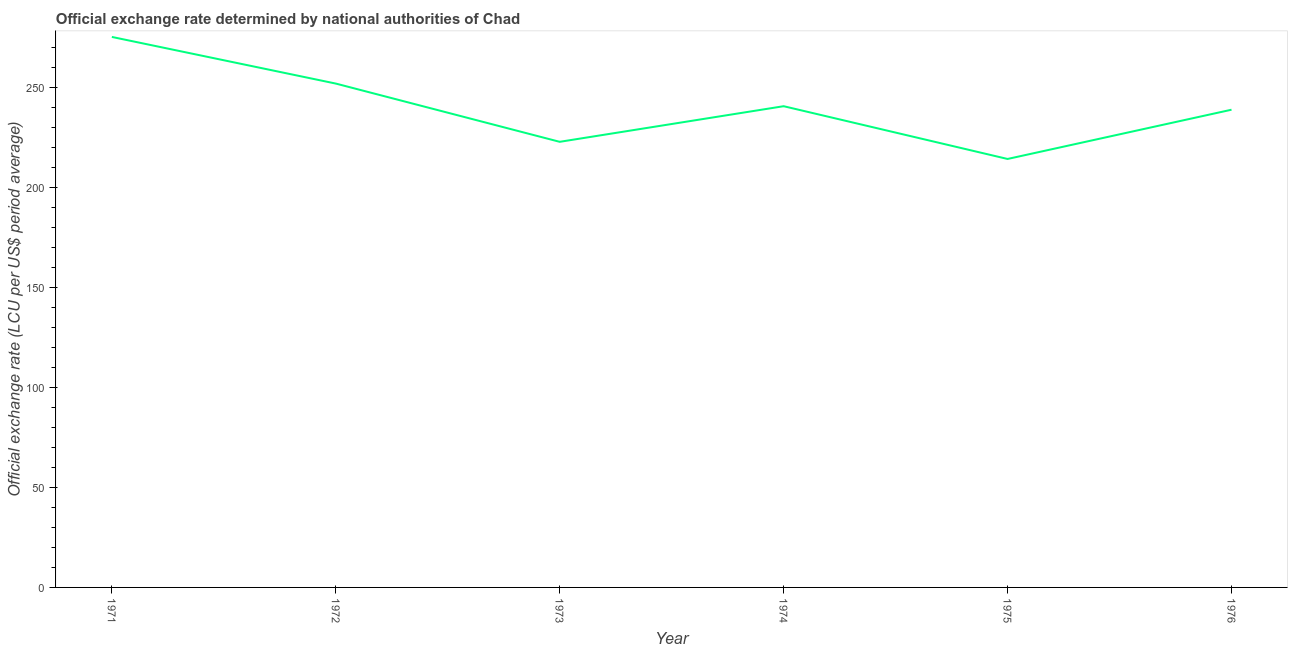What is the official exchange rate in 1975?
Your answer should be compact. 214.31. Across all years, what is the maximum official exchange rate?
Provide a succinct answer. 275.36. Across all years, what is the minimum official exchange rate?
Offer a very short reply. 214.31. In which year was the official exchange rate maximum?
Your response must be concise. 1971. In which year was the official exchange rate minimum?
Your answer should be very brief. 1975. What is the sum of the official exchange rate?
Your response must be concise. 1444.24. What is the difference between the official exchange rate in 1975 and 1976?
Your answer should be compact. -24.64. What is the average official exchange rate per year?
Provide a succinct answer. 240.71. What is the median official exchange rate?
Your answer should be compact. 239.83. What is the ratio of the official exchange rate in 1971 to that in 1974?
Your response must be concise. 1.14. Is the difference between the official exchange rate in 1974 and 1976 greater than the difference between any two years?
Provide a short and direct response. No. What is the difference between the highest and the second highest official exchange rate?
Your answer should be very brief. 23.33. Is the sum of the official exchange rate in 1974 and 1976 greater than the maximum official exchange rate across all years?
Give a very brief answer. Yes. What is the difference between the highest and the lowest official exchange rate?
Your response must be concise. 61.04. Are the values on the major ticks of Y-axis written in scientific E-notation?
Your response must be concise. No. Does the graph contain any zero values?
Your response must be concise. No. Does the graph contain grids?
Offer a very short reply. No. What is the title of the graph?
Provide a short and direct response. Official exchange rate determined by national authorities of Chad. What is the label or title of the Y-axis?
Keep it short and to the point. Official exchange rate (LCU per US$ period average). What is the Official exchange rate (LCU per US$ period average) of 1971?
Your response must be concise. 275.36. What is the Official exchange rate (LCU per US$ period average) of 1972?
Your answer should be very brief. 252.03. What is the Official exchange rate (LCU per US$ period average) of 1973?
Your answer should be compact. 222.89. What is the Official exchange rate (LCU per US$ period average) in 1974?
Make the answer very short. 240.7. What is the Official exchange rate (LCU per US$ period average) of 1975?
Your answer should be very brief. 214.31. What is the Official exchange rate (LCU per US$ period average) in 1976?
Provide a succinct answer. 238.95. What is the difference between the Official exchange rate (LCU per US$ period average) in 1971 and 1972?
Offer a very short reply. 23.33. What is the difference between the Official exchange rate (LCU per US$ period average) in 1971 and 1973?
Offer a terse response. 52.47. What is the difference between the Official exchange rate (LCU per US$ period average) in 1971 and 1974?
Provide a short and direct response. 34.65. What is the difference between the Official exchange rate (LCU per US$ period average) in 1971 and 1975?
Offer a very short reply. 61.04. What is the difference between the Official exchange rate (LCU per US$ period average) in 1971 and 1976?
Offer a terse response. 36.41. What is the difference between the Official exchange rate (LCU per US$ period average) in 1972 and 1973?
Your answer should be very brief. 29.14. What is the difference between the Official exchange rate (LCU per US$ period average) in 1972 and 1974?
Your answer should be very brief. 11.32. What is the difference between the Official exchange rate (LCU per US$ period average) in 1972 and 1975?
Provide a succinct answer. 37.71. What is the difference between the Official exchange rate (LCU per US$ period average) in 1972 and 1976?
Offer a terse response. 13.08. What is the difference between the Official exchange rate (LCU per US$ period average) in 1973 and 1974?
Provide a short and direct response. -17.82. What is the difference between the Official exchange rate (LCU per US$ period average) in 1973 and 1975?
Give a very brief answer. 8.58. What is the difference between the Official exchange rate (LCU per US$ period average) in 1973 and 1976?
Offer a very short reply. -16.06. What is the difference between the Official exchange rate (LCU per US$ period average) in 1974 and 1975?
Offer a terse response. 26.39. What is the difference between the Official exchange rate (LCU per US$ period average) in 1974 and 1976?
Your answer should be very brief. 1.75. What is the difference between the Official exchange rate (LCU per US$ period average) in 1975 and 1976?
Provide a succinct answer. -24.64. What is the ratio of the Official exchange rate (LCU per US$ period average) in 1971 to that in 1972?
Make the answer very short. 1.09. What is the ratio of the Official exchange rate (LCU per US$ period average) in 1971 to that in 1973?
Keep it short and to the point. 1.24. What is the ratio of the Official exchange rate (LCU per US$ period average) in 1971 to that in 1974?
Your answer should be very brief. 1.14. What is the ratio of the Official exchange rate (LCU per US$ period average) in 1971 to that in 1975?
Your response must be concise. 1.28. What is the ratio of the Official exchange rate (LCU per US$ period average) in 1971 to that in 1976?
Provide a succinct answer. 1.15. What is the ratio of the Official exchange rate (LCU per US$ period average) in 1972 to that in 1973?
Provide a short and direct response. 1.13. What is the ratio of the Official exchange rate (LCU per US$ period average) in 1972 to that in 1974?
Make the answer very short. 1.05. What is the ratio of the Official exchange rate (LCU per US$ period average) in 1972 to that in 1975?
Make the answer very short. 1.18. What is the ratio of the Official exchange rate (LCU per US$ period average) in 1972 to that in 1976?
Your answer should be compact. 1.05. What is the ratio of the Official exchange rate (LCU per US$ period average) in 1973 to that in 1974?
Your response must be concise. 0.93. What is the ratio of the Official exchange rate (LCU per US$ period average) in 1973 to that in 1976?
Offer a terse response. 0.93. What is the ratio of the Official exchange rate (LCU per US$ period average) in 1974 to that in 1975?
Keep it short and to the point. 1.12. What is the ratio of the Official exchange rate (LCU per US$ period average) in 1975 to that in 1976?
Your answer should be compact. 0.9. 